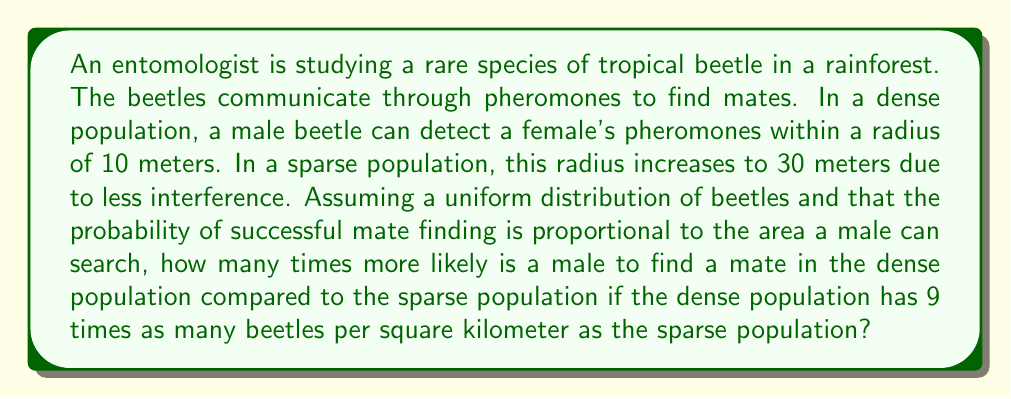Provide a solution to this math problem. Let's approach this step-by-step:

1) The area a male beetle can search is proportional to the square of the radius:
   $$A = \pi r^2$$

2) For the dense population:
   $$A_d = \pi (10\text{ m})^2 = 100\pi \text{ m}^2$$

3) For the sparse population:
   $$A_s = \pi (30\text{ m})^2 = 900\pi \text{ m}^2$$

4) The probability of finding a mate is proportional to both the area searched and the population density. Let's call the probability $P$, the area $A$, and the density $D$. Then:
   $$P \propto A \cdot D$$

5) We're told that the dense population has 9 times as many beetles per square kilometer. Let's represent this as:
   $$D_d = 9D_s$$

6) Now, let's set up the ratio of probabilities:
   $$\frac{P_d}{P_s} = \frac{A_d \cdot D_d}{A_s \cdot D_s} = \frac{100\pi \cdot 9D_s}{900\pi \cdot D_s}$$

7) The $\pi$ and $D_s$ cancel out:
   $$\frac{P_d}{P_s} = \frac{900}{900} = 1$$

Therefore, despite the differences in search area and population density, the probabilities of finding a mate are equal in both scenarios.
Answer: The male beetle is equally likely to find a mate in both the dense and sparse populations. The ratio of probabilities is 1:1. 